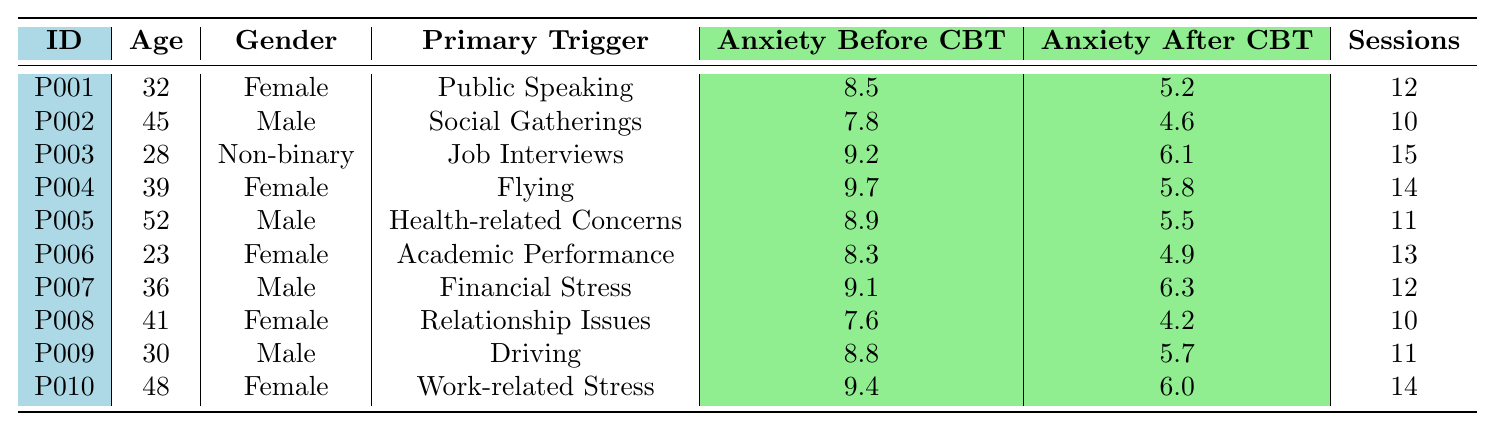What is the highest anxiety level reported before CBT sessions? Looking through the table, I see the highest value under "Anxiety Before CBT" is 9.7, which corresponds to the participant with the primary trigger "Flying."
Answer: 9.7 Which participant had the lowest anxiety level after CBT sessions? The lowest value under "Anxiety After CBT" is 4.2, associated with the participant experiencing "Relationship Issues."
Answer: 4.2 How many sessions did the participant with the highest anxiety level before CBT attend? The participant with the highest anxiety level before CBT (9.7) attended 14 sessions, as noted in the same row of the table.
Answer: 14 What is the average anxiety level after CBT for females? I sum the anxiety levels after CBT for females (5.2, 5.8, 4.9, 4.2, 6.0) to get 26.1. There are 5 females, so the average is 26.1 / 5 = 5.22.
Answer: 5.22 Was there any participant whose anxiety level did not drop after CBT sessions? By comparing the "Anxiety Before CBT" and "Anxiety After CBT" levels for all participants, I find that all participants' anxiety levels decreased, confirming that none had an increase.
Answer: No What is the difference between the highest and lowest anxiety levels after CBT sessions? The highest anxiety level after CBT is 6.3 and the lowest is 4.2. Taking the difference (6.3 - 4.2) gives 2.1.
Answer: 2.1 Which gender had the highest average anxiety level before CBT? I calculate the average anxiety level before CBT for males (7.8 + 9.2 + 8.9 + 9.1 + 8.8) which totals to 43.8 over 5 males, giving an average of 8.76. For females (8.5 + 9.7 + 8.3 + 7.6 + 9.4), the total is 43.5 over 5 females, averaging 8.7. Comparing the two averages, males had the higher anxiety level before CBT.
Answer: Males How many participants had an anxiety level greater than 8 before CBT but reduced to below 6 after CBT? I check each participant and find that P001 (8.5 to 5.2), P004 (9.7 to 5.8), P003 (9.2 to 6.1), and P010 (9.4 to 6.0) had anxiety levels greater than 8 before CBT and reduced to below 6 after treatment, totaling 4 participants.
Answer: 4 What percentage of participants attended more than 12 sessions? The participants who attended more than 12 sessions are P003, P004, P006, P001, and P010, totaling 5 out of 10 participants, resulting in (5/10) * 100 = 50%.
Answer: 50% 